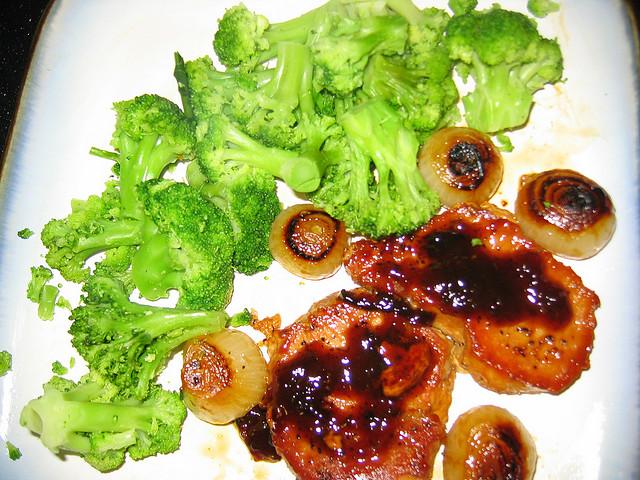Is this a good meal for a vegetarian?
Write a very short answer. No. Is the broccoli raw?
Concise answer only. No. What color is the plate?
Write a very short answer. White. 